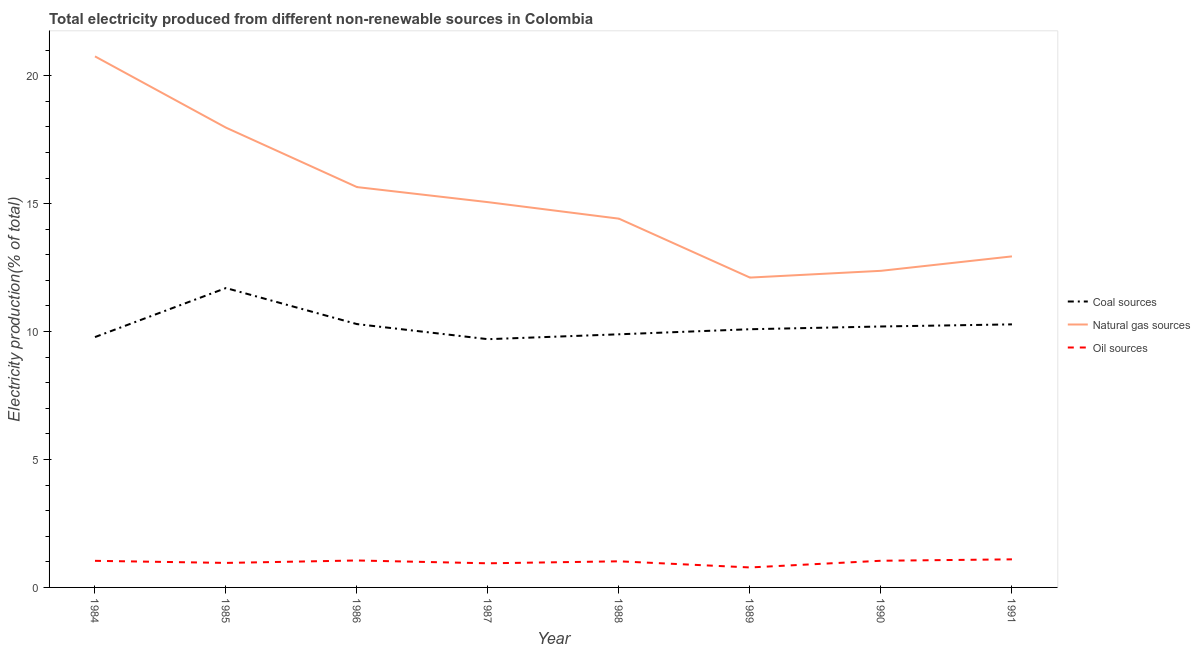Does the line corresponding to percentage of electricity produced by oil sources intersect with the line corresponding to percentage of electricity produced by natural gas?
Provide a succinct answer. No. Is the number of lines equal to the number of legend labels?
Ensure brevity in your answer.  Yes. What is the percentage of electricity produced by coal in 1988?
Your answer should be very brief. 9.89. Across all years, what is the maximum percentage of electricity produced by natural gas?
Your response must be concise. 20.76. Across all years, what is the minimum percentage of electricity produced by natural gas?
Your response must be concise. 12.11. What is the total percentage of electricity produced by oil sources in the graph?
Offer a very short reply. 7.94. What is the difference between the percentage of electricity produced by natural gas in 1988 and that in 1990?
Keep it short and to the point. 2.04. What is the difference between the percentage of electricity produced by oil sources in 1988 and the percentage of electricity produced by coal in 1991?
Your answer should be very brief. -9.26. What is the average percentage of electricity produced by natural gas per year?
Your answer should be compact. 15.16. In the year 1984, what is the difference between the percentage of electricity produced by coal and percentage of electricity produced by natural gas?
Offer a very short reply. -10.97. In how many years, is the percentage of electricity produced by oil sources greater than 18 %?
Ensure brevity in your answer.  0. What is the ratio of the percentage of electricity produced by natural gas in 1984 to that in 1986?
Your response must be concise. 1.33. What is the difference between the highest and the second highest percentage of electricity produced by coal?
Your response must be concise. 1.41. What is the difference between the highest and the lowest percentage of electricity produced by oil sources?
Offer a terse response. 0.32. In how many years, is the percentage of electricity produced by coal greater than the average percentage of electricity produced by coal taken over all years?
Ensure brevity in your answer.  3. Is the sum of the percentage of electricity produced by natural gas in 1984 and 1991 greater than the maximum percentage of electricity produced by oil sources across all years?
Offer a very short reply. Yes. Does the percentage of electricity produced by oil sources monotonically increase over the years?
Your response must be concise. No. Is the percentage of electricity produced by oil sources strictly less than the percentage of electricity produced by natural gas over the years?
Ensure brevity in your answer.  Yes. What is the difference between two consecutive major ticks on the Y-axis?
Ensure brevity in your answer.  5. Does the graph contain grids?
Your answer should be very brief. No. Where does the legend appear in the graph?
Ensure brevity in your answer.  Center right. How are the legend labels stacked?
Your response must be concise. Vertical. What is the title of the graph?
Ensure brevity in your answer.  Total electricity produced from different non-renewable sources in Colombia. What is the label or title of the Y-axis?
Make the answer very short. Electricity production(% of total). What is the Electricity production(% of total) in Coal sources in 1984?
Your answer should be compact. 9.78. What is the Electricity production(% of total) in Natural gas sources in 1984?
Ensure brevity in your answer.  20.76. What is the Electricity production(% of total) of Oil sources in 1984?
Your answer should be very brief. 1.04. What is the Electricity production(% of total) of Coal sources in 1985?
Keep it short and to the point. 11.7. What is the Electricity production(% of total) of Natural gas sources in 1985?
Keep it short and to the point. 17.97. What is the Electricity production(% of total) of Oil sources in 1985?
Provide a succinct answer. 0.96. What is the Electricity production(% of total) of Coal sources in 1986?
Your response must be concise. 10.29. What is the Electricity production(% of total) in Natural gas sources in 1986?
Offer a terse response. 15.65. What is the Electricity production(% of total) in Oil sources in 1986?
Offer a terse response. 1.05. What is the Electricity production(% of total) in Coal sources in 1987?
Ensure brevity in your answer.  9.7. What is the Electricity production(% of total) in Natural gas sources in 1987?
Ensure brevity in your answer.  15.06. What is the Electricity production(% of total) in Oil sources in 1987?
Keep it short and to the point. 0.94. What is the Electricity production(% of total) of Coal sources in 1988?
Your answer should be compact. 9.89. What is the Electricity production(% of total) of Natural gas sources in 1988?
Make the answer very short. 14.41. What is the Electricity production(% of total) in Oil sources in 1988?
Provide a succinct answer. 1.02. What is the Electricity production(% of total) of Coal sources in 1989?
Offer a very short reply. 10.09. What is the Electricity production(% of total) of Natural gas sources in 1989?
Offer a very short reply. 12.11. What is the Electricity production(% of total) of Oil sources in 1989?
Provide a succinct answer. 0.78. What is the Electricity production(% of total) of Coal sources in 1990?
Your answer should be very brief. 10.2. What is the Electricity production(% of total) in Natural gas sources in 1990?
Your answer should be compact. 12.37. What is the Electricity production(% of total) of Oil sources in 1990?
Offer a very short reply. 1.04. What is the Electricity production(% of total) of Coal sources in 1991?
Your answer should be compact. 10.28. What is the Electricity production(% of total) in Natural gas sources in 1991?
Make the answer very short. 12.94. What is the Electricity production(% of total) of Oil sources in 1991?
Provide a succinct answer. 1.1. Across all years, what is the maximum Electricity production(% of total) in Coal sources?
Provide a succinct answer. 11.7. Across all years, what is the maximum Electricity production(% of total) of Natural gas sources?
Provide a short and direct response. 20.76. Across all years, what is the maximum Electricity production(% of total) of Oil sources?
Make the answer very short. 1.1. Across all years, what is the minimum Electricity production(% of total) of Coal sources?
Ensure brevity in your answer.  9.7. Across all years, what is the minimum Electricity production(% of total) in Natural gas sources?
Offer a terse response. 12.11. Across all years, what is the minimum Electricity production(% of total) of Oil sources?
Your answer should be compact. 0.78. What is the total Electricity production(% of total) in Coal sources in the graph?
Provide a succinct answer. 81.95. What is the total Electricity production(% of total) of Natural gas sources in the graph?
Give a very brief answer. 121.27. What is the total Electricity production(% of total) in Oil sources in the graph?
Provide a succinct answer. 7.94. What is the difference between the Electricity production(% of total) in Coal sources in 1984 and that in 1985?
Your answer should be very brief. -1.92. What is the difference between the Electricity production(% of total) in Natural gas sources in 1984 and that in 1985?
Your response must be concise. 2.79. What is the difference between the Electricity production(% of total) of Oil sources in 1984 and that in 1985?
Keep it short and to the point. 0.08. What is the difference between the Electricity production(% of total) in Coal sources in 1984 and that in 1986?
Your answer should be very brief. -0.51. What is the difference between the Electricity production(% of total) in Natural gas sources in 1984 and that in 1986?
Give a very brief answer. 5.11. What is the difference between the Electricity production(% of total) in Oil sources in 1984 and that in 1986?
Make the answer very short. -0.01. What is the difference between the Electricity production(% of total) of Coal sources in 1984 and that in 1987?
Your answer should be very brief. 0.08. What is the difference between the Electricity production(% of total) in Natural gas sources in 1984 and that in 1987?
Offer a very short reply. 5.7. What is the difference between the Electricity production(% of total) in Oil sources in 1984 and that in 1987?
Keep it short and to the point. 0.1. What is the difference between the Electricity production(% of total) of Coal sources in 1984 and that in 1988?
Make the answer very short. -0.11. What is the difference between the Electricity production(% of total) in Natural gas sources in 1984 and that in 1988?
Offer a terse response. 6.34. What is the difference between the Electricity production(% of total) of Oil sources in 1984 and that in 1988?
Offer a very short reply. 0.02. What is the difference between the Electricity production(% of total) in Coal sources in 1984 and that in 1989?
Make the answer very short. -0.31. What is the difference between the Electricity production(% of total) of Natural gas sources in 1984 and that in 1989?
Provide a short and direct response. 8.65. What is the difference between the Electricity production(% of total) in Oil sources in 1984 and that in 1989?
Give a very brief answer. 0.26. What is the difference between the Electricity production(% of total) of Coal sources in 1984 and that in 1990?
Your answer should be very brief. -0.41. What is the difference between the Electricity production(% of total) of Natural gas sources in 1984 and that in 1990?
Give a very brief answer. 8.38. What is the difference between the Electricity production(% of total) in Oil sources in 1984 and that in 1990?
Ensure brevity in your answer.  -0. What is the difference between the Electricity production(% of total) in Coal sources in 1984 and that in 1991?
Offer a terse response. -0.5. What is the difference between the Electricity production(% of total) of Natural gas sources in 1984 and that in 1991?
Offer a very short reply. 7.82. What is the difference between the Electricity production(% of total) of Oil sources in 1984 and that in 1991?
Ensure brevity in your answer.  -0.06. What is the difference between the Electricity production(% of total) in Coal sources in 1985 and that in 1986?
Offer a very short reply. 1.41. What is the difference between the Electricity production(% of total) in Natural gas sources in 1985 and that in 1986?
Your response must be concise. 2.32. What is the difference between the Electricity production(% of total) of Oil sources in 1985 and that in 1986?
Your answer should be very brief. -0.1. What is the difference between the Electricity production(% of total) of Coal sources in 1985 and that in 1987?
Provide a succinct answer. 2. What is the difference between the Electricity production(% of total) of Natural gas sources in 1985 and that in 1987?
Keep it short and to the point. 2.91. What is the difference between the Electricity production(% of total) in Oil sources in 1985 and that in 1987?
Keep it short and to the point. 0.01. What is the difference between the Electricity production(% of total) in Coal sources in 1985 and that in 1988?
Ensure brevity in your answer.  1.81. What is the difference between the Electricity production(% of total) of Natural gas sources in 1985 and that in 1988?
Your response must be concise. 3.56. What is the difference between the Electricity production(% of total) in Oil sources in 1985 and that in 1988?
Provide a short and direct response. -0.06. What is the difference between the Electricity production(% of total) in Coal sources in 1985 and that in 1989?
Your response must be concise. 1.61. What is the difference between the Electricity production(% of total) in Natural gas sources in 1985 and that in 1989?
Your answer should be compact. 5.86. What is the difference between the Electricity production(% of total) in Oil sources in 1985 and that in 1989?
Your response must be concise. 0.18. What is the difference between the Electricity production(% of total) of Coal sources in 1985 and that in 1990?
Provide a succinct answer. 1.5. What is the difference between the Electricity production(% of total) in Natural gas sources in 1985 and that in 1990?
Offer a very short reply. 5.6. What is the difference between the Electricity production(% of total) in Oil sources in 1985 and that in 1990?
Offer a very short reply. -0.08. What is the difference between the Electricity production(% of total) of Coal sources in 1985 and that in 1991?
Provide a short and direct response. 1.42. What is the difference between the Electricity production(% of total) of Natural gas sources in 1985 and that in 1991?
Provide a short and direct response. 5.03. What is the difference between the Electricity production(% of total) of Oil sources in 1985 and that in 1991?
Your response must be concise. -0.14. What is the difference between the Electricity production(% of total) of Coal sources in 1986 and that in 1987?
Your answer should be very brief. 0.59. What is the difference between the Electricity production(% of total) in Natural gas sources in 1986 and that in 1987?
Your answer should be very brief. 0.59. What is the difference between the Electricity production(% of total) in Oil sources in 1986 and that in 1987?
Offer a terse response. 0.11. What is the difference between the Electricity production(% of total) of Coal sources in 1986 and that in 1988?
Give a very brief answer. 0.4. What is the difference between the Electricity production(% of total) in Natural gas sources in 1986 and that in 1988?
Give a very brief answer. 1.23. What is the difference between the Electricity production(% of total) of Oil sources in 1986 and that in 1988?
Make the answer very short. 0.03. What is the difference between the Electricity production(% of total) of Coal sources in 1986 and that in 1989?
Your answer should be very brief. 0.2. What is the difference between the Electricity production(% of total) in Natural gas sources in 1986 and that in 1989?
Keep it short and to the point. 3.54. What is the difference between the Electricity production(% of total) in Oil sources in 1986 and that in 1989?
Offer a terse response. 0.27. What is the difference between the Electricity production(% of total) of Coal sources in 1986 and that in 1990?
Your answer should be very brief. 0.09. What is the difference between the Electricity production(% of total) of Natural gas sources in 1986 and that in 1990?
Your response must be concise. 3.27. What is the difference between the Electricity production(% of total) of Oil sources in 1986 and that in 1990?
Your answer should be compact. 0.01. What is the difference between the Electricity production(% of total) of Coal sources in 1986 and that in 1991?
Ensure brevity in your answer.  0.01. What is the difference between the Electricity production(% of total) of Natural gas sources in 1986 and that in 1991?
Keep it short and to the point. 2.71. What is the difference between the Electricity production(% of total) of Oil sources in 1986 and that in 1991?
Make the answer very short. -0.04. What is the difference between the Electricity production(% of total) of Coal sources in 1987 and that in 1988?
Your answer should be very brief. -0.19. What is the difference between the Electricity production(% of total) in Natural gas sources in 1987 and that in 1988?
Your answer should be very brief. 0.65. What is the difference between the Electricity production(% of total) in Oil sources in 1987 and that in 1988?
Keep it short and to the point. -0.08. What is the difference between the Electricity production(% of total) in Coal sources in 1987 and that in 1989?
Offer a terse response. -0.39. What is the difference between the Electricity production(% of total) in Natural gas sources in 1987 and that in 1989?
Provide a succinct answer. 2.95. What is the difference between the Electricity production(% of total) in Oil sources in 1987 and that in 1989?
Offer a terse response. 0.16. What is the difference between the Electricity production(% of total) of Coal sources in 1987 and that in 1990?
Offer a terse response. -0.5. What is the difference between the Electricity production(% of total) in Natural gas sources in 1987 and that in 1990?
Give a very brief answer. 2.68. What is the difference between the Electricity production(% of total) of Oil sources in 1987 and that in 1990?
Provide a short and direct response. -0.1. What is the difference between the Electricity production(% of total) of Coal sources in 1987 and that in 1991?
Make the answer very short. -0.58. What is the difference between the Electricity production(% of total) of Natural gas sources in 1987 and that in 1991?
Keep it short and to the point. 2.12. What is the difference between the Electricity production(% of total) in Oil sources in 1987 and that in 1991?
Offer a very short reply. -0.15. What is the difference between the Electricity production(% of total) of Coal sources in 1988 and that in 1989?
Provide a succinct answer. -0.2. What is the difference between the Electricity production(% of total) of Natural gas sources in 1988 and that in 1989?
Provide a short and direct response. 2.3. What is the difference between the Electricity production(% of total) in Oil sources in 1988 and that in 1989?
Keep it short and to the point. 0.24. What is the difference between the Electricity production(% of total) in Coal sources in 1988 and that in 1990?
Your response must be concise. -0.31. What is the difference between the Electricity production(% of total) of Natural gas sources in 1988 and that in 1990?
Provide a succinct answer. 2.04. What is the difference between the Electricity production(% of total) of Oil sources in 1988 and that in 1990?
Your response must be concise. -0.02. What is the difference between the Electricity production(% of total) of Coal sources in 1988 and that in 1991?
Your response must be concise. -0.39. What is the difference between the Electricity production(% of total) in Natural gas sources in 1988 and that in 1991?
Your response must be concise. 1.47. What is the difference between the Electricity production(% of total) of Oil sources in 1988 and that in 1991?
Give a very brief answer. -0.08. What is the difference between the Electricity production(% of total) of Coal sources in 1989 and that in 1990?
Give a very brief answer. -0.11. What is the difference between the Electricity production(% of total) of Natural gas sources in 1989 and that in 1990?
Keep it short and to the point. -0.26. What is the difference between the Electricity production(% of total) in Oil sources in 1989 and that in 1990?
Offer a very short reply. -0.26. What is the difference between the Electricity production(% of total) of Coal sources in 1989 and that in 1991?
Ensure brevity in your answer.  -0.19. What is the difference between the Electricity production(% of total) in Natural gas sources in 1989 and that in 1991?
Your answer should be compact. -0.83. What is the difference between the Electricity production(% of total) in Oil sources in 1989 and that in 1991?
Your answer should be compact. -0.32. What is the difference between the Electricity production(% of total) of Coal sources in 1990 and that in 1991?
Offer a very short reply. -0.08. What is the difference between the Electricity production(% of total) of Natural gas sources in 1990 and that in 1991?
Ensure brevity in your answer.  -0.56. What is the difference between the Electricity production(% of total) of Oil sources in 1990 and that in 1991?
Provide a short and direct response. -0.06. What is the difference between the Electricity production(% of total) of Coal sources in 1984 and the Electricity production(% of total) of Natural gas sources in 1985?
Give a very brief answer. -8.19. What is the difference between the Electricity production(% of total) of Coal sources in 1984 and the Electricity production(% of total) of Oil sources in 1985?
Provide a short and direct response. 8.83. What is the difference between the Electricity production(% of total) in Natural gas sources in 1984 and the Electricity production(% of total) in Oil sources in 1985?
Keep it short and to the point. 19.8. What is the difference between the Electricity production(% of total) in Coal sources in 1984 and the Electricity production(% of total) in Natural gas sources in 1986?
Make the answer very short. -5.86. What is the difference between the Electricity production(% of total) of Coal sources in 1984 and the Electricity production(% of total) of Oil sources in 1986?
Your response must be concise. 8.73. What is the difference between the Electricity production(% of total) in Natural gas sources in 1984 and the Electricity production(% of total) in Oil sources in 1986?
Provide a succinct answer. 19.7. What is the difference between the Electricity production(% of total) of Coal sources in 1984 and the Electricity production(% of total) of Natural gas sources in 1987?
Make the answer very short. -5.27. What is the difference between the Electricity production(% of total) of Coal sources in 1984 and the Electricity production(% of total) of Oil sources in 1987?
Make the answer very short. 8.84. What is the difference between the Electricity production(% of total) in Natural gas sources in 1984 and the Electricity production(% of total) in Oil sources in 1987?
Offer a very short reply. 19.81. What is the difference between the Electricity production(% of total) in Coal sources in 1984 and the Electricity production(% of total) in Natural gas sources in 1988?
Offer a terse response. -4.63. What is the difference between the Electricity production(% of total) in Coal sources in 1984 and the Electricity production(% of total) in Oil sources in 1988?
Offer a very short reply. 8.76. What is the difference between the Electricity production(% of total) in Natural gas sources in 1984 and the Electricity production(% of total) in Oil sources in 1988?
Offer a terse response. 19.74. What is the difference between the Electricity production(% of total) of Coal sources in 1984 and the Electricity production(% of total) of Natural gas sources in 1989?
Your answer should be compact. -2.33. What is the difference between the Electricity production(% of total) in Coal sources in 1984 and the Electricity production(% of total) in Oil sources in 1989?
Provide a succinct answer. 9. What is the difference between the Electricity production(% of total) of Natural gas sources in 1984 and the Electricity production(% of total) of Oil sources in 1989?
Ensure brevity in your answer.  19.98. What is the difference between the Electricity production(% of total) in Coal sources in 1984 and the Electricity production(% of total) in Natural gas sources in 1990?
Offer a very short reply. -2.59. What is the difference between the Electricity production(% of total) in Coal sources in 1984 and the Electricity production(% of total) in Oil sources in 1990?
Ensure brevity in your answer.  8.74. What is the difference between the Electricity production(% of total) in Natural gas sources in 1984 and the Electricity production(% of total) in Oil sources in 1990?
Offer a terse response. 19.71. What is the difference between the Electricity production(% of total) of Coal sources in 1984 and the Electricity production(% of total) of Natural gas sources in 1991?
Ensure brevity in your answer.  -3.15. What is the difference between the Electricity production(% of total) in Coal sources in 1984 and the Electricity production(% of total) in Oil sources in 1991?
Provide a short and direct response. 8.69. What is the difference between the Electricity production(% of total) in Natural gas sources in 1984 and the Electricity production(% of total) in Oil sources in 1991?
Provide a succinct answer. 19.66. What is the difference between the Electricity production(% of total) in Coal sources in 1985 and the Electricity production(% of total) in Natural gas sources in 1986?
Ensure brevity in your answer.  -3.95. What is the difference between the Electricity production(% of total) of Coal sources in 1985 and the Electricity production(% of total) of Oil sources in 1986?
Offer a terse response. 10.65. What is the difference between the Electricity production(% of total) of Natural gas sources in 1985 and the Electricity production(% of total) of Oil sources in 1986?
Your answer should be very brief. 16.92. What is the difference between the Electricity production(% of total) in Coal sources in 1985 and the Electricity production(% of total) in Natural gas sources in 1987?
Make the answer very short. -3.36. What is the difference between the Electricity production(% of total) of Coal sources in 1985 and the Electricity production(% of total) of Oil sources in 1987?
Provide a succinct answer. 10.76. What is the difference between the Electricity production(% of total) of Natural gas sources in 1985 and the Electricity production(% of total) of Oil sources in 1987?
Your response must be concise. 17.03. What is the difference between the Electricity production(% of total) of Coal sources in 1985 and the Electricity production(% of total) of Natural gas sources in 1988?
Your response must be concise. -2.71. What is the difference between the Electricity production(% of total) of Coal sources in 1985 and the Electricity production(% of total) of Oil sources in 1988?
Your answer should be very brief. 10.68. What is the difference between the Electricity production(% of total) of Natural gas sources in 1985 and the Electricity production(% of total) of Oil sources in 1988?
Give a very brief answer. 16.95. What is the difference between the Electricity production(% of total) of Coal sources in 1985 and the Electricity production(% of total) of Natural gas sources in 1989?
Give a very brief answer. -0.41. What is the difference between the Electricity production(% of total) in Coal sources in 1985 and the Electricity production(% of total) in Oil sources in 1989?
Make the answer very short. 10.92. What is the difference between the Electricity production(% of total) in Natural gas sources in 1985 and the Electricity production(% of total) in Oil sources in 1989?
Make the answer very short. 17.19. What is the difference between the Electricity production(% of total) in Coal sources in 1985 and the Electricity production(% of total) in Natural gas sources in 1990?
Make the answer very short. -0.67. What is the difference between the Electricity production(% of total) in Coal sources in 1985 and the Electricity production(% of total) in Oil sources in 1990?
Offer a terse response. 10.66. What is the difference between the Electricity production(% of total) of Natural gas sources in 1985 and the Electricity production(% of total) of Oil sources in 1990?
Offer a terse response. 16.93. What is the difference between the Electricity production(% of total) of Coal sources in 1985 and the Electricity production(% of total) of Natural gas sources in 1991?
Your response must be concise. -1.24. What is the difference between the Electricity production(% of total) in Coal sources in 1985 and the Electricity production(% of total) in Oil sources in 1991?
Ensure brevity in your answer.  10.6. What is the difference between the Electricity production(% of total) in Natural gas sources in 1985 and the Electricity production(% of total) in Oil sources in 1991?
Make the answer very short. 16.87. What is the difference between the Electricity production(% of total) in Coal sources in 1986 and the Electricity production(% of total) in Natural gas sources in 1987?
Your answer should be very brief. -4.77. What is the difference between the Electricity production(% of total) in Coal sources in 1986 and the Electricity production(% of total) in Oil sources in 1987?
Your response must be concise. 9.35. What is the difference between the Electricity production(% of total) of Natural gas sources in 1986 and the Electricity production(% of total) of Oil sources in 1987?
Keep it short and to the point. 14.7. What is the difference between the Electricity production(% of total) in Coal sources in 1986 and the Electricity production(% of total) in Natural gas sources in 1988?
Your answer should be very brief. -4.12. What is the difference between the Electricity production(% of total) in Coal sources in 1986 and the Electricity production(% of total) in Oil sources in 1988?
Ensure brevity in your answer.  9.27. What is the difference between the Electricity production(% of total) in Natural gas sources in 1986 and the Electricity production(% of total) in Oil sources in 1988?
Give a very brief answer. 14.63. What is the difference between the Electricity production(% of total) in Coal sources in 1986 and the Electricity production(% of total) in Natural gas sources in 1989?
Make the answer very short. -1.82. What is the difference between the Electricity production(% of total) in Coal sources in 1986 and the Electricity production(% of total) in Oil sources in 1989?
Keep it short and to the point. 9.51. What is the difference between the Electricity production(% of total) of Natural gas sources in 1986 and the Electricity production(% of total) of Oil sources in 1989?
Your response must be concise. 14.87. What is the difference between the Electricity production(% of total) of Coal sources in 1986 and the Electricity production(% of total) of Natural gas sources in 1990?
Offer a terse response. -2.08. What is the difference between the Electricity production(% of total) in Coal sources in 1986 and the Electricity production(% of total) in Oil sources in 1990?
Ensure brevity in your answer.  9.25. What is the difference between the Electricity production(% of total) in Natural gas sources in 1986 and the Electricity production(% of total) in Oil sources in 1990?
Your response must be concise. 14.6. What is the difference between the Electricity production(% of total) in Coal sources in 1986 and the Electricity production(% of total) in Natural gas sources in 1991?
Provide a succinct answer. -2.65. What is the difference between the Electricity production(% of total) of Coal sources in 1986 and the Electricity production(% of total) of Oil sources in 1991?
Ensure brevity in your answer.  9.19. What is the difference between the Electricity production(% of total) in Natural gas sources in 1986 and the Electricity production(% of total) in Oil sources in 1991?
Provide a succinct answer. 14.55. What is the difference between the Electricity production(% of total) in Coal sources in 1987 and the Electricity production(% of total) in Natural gas sources in 1988?
Provide a succinct answer. -4.71. What is the difference between the Electricity production(% of total) of Coal sources in 1987 and the Electricity production(% of total) of Oil sources in 1988?
Make the answer very short. 8.68. What is the difference between the Electricity production(% of total) of Natural gas sources in 1987 and the Electricity production(% of total) of Oil sources in 1988?
Your answer should be compact. 14.04. What is the difference between the Electricity production(% of total) of Coal sources in 1987 and the Electricity production(% of total) of Natural gas sources in 1989?
Give a very brief answer. -2.41. What is the difference between the Electricity production(% of total) in Coal sources in 1987 and the Electricity production(% of total) in Oil sources in 1989?
Offer a terse response. 8.92. What is the difference between the Electricity production(% of total) of Natural gas sources in 1987 and the Electricity production(% of total) of Oil sources in 1989?
Your answer should be compact. 14.28. What is the difference between the Electricity production(% of total) of Coal sources in 1987 and the Electricity production(% of total) of Natural gas sources in 1990?
Offer a very short reply. -2.67. What is the difference between the Electricity production(% of total) of Coal sources in 1987 and the Electricity production(% of total) of Oil sources in 1990?
Provide a short and direct response. 8.66. What is the difference between the Electricity production(% of total) in Natural gas sources in 1987 and the Electricity production(% of total) in Oil sources in 1990?
Provide a short and direct response. 14.02. What is the difference between the Electricity production(% of total) of Coal sources in 1987 and the Electricity production(% of total) of Natural gas sources in 1991?
Offer a very short reply. -3.24. What is the difference between the Electricity production(% of total) in Coal sources in 1987 and the Electricity production(% of total) in Oil sources in 1991?
Offer a very short reply. 8.6. What is the difference between the Electricity production(% of total) in Natural gas sources in 1987 and the Electricity production(% of total) in Oil sources in 1991?
Give a very brief answer. 13.96. What is the difference between the Electricity production(% of total) in Coal sources in 1988 and the Electricity production(% of total) in Natural gas sources in 1989?
Offer a very short reply. -2.22. What is the difference between the Electricity production(% of total) in Coal sources in 1988 and the Electricity production(% of total) in Oil sources in 1989?
Provide a succinct answer. 9.11. What is the difference between the Electricity production(% of total) of Natural gas sources in 1988 and the Electricity production(% of total) of Oil sources in 1989?
Your response must be concise. 13.63. What is the difference between the Electricity production(% of total) of Coal sources in 1988 and the Electricity production(% of total) of Natural gas sources in 1990?
Provide a short and direct response. -2.48. What is the difference between the Electricity production(% of total) in Coal sources in 1988 and the Electricity production(% of total) in Oil sources in 1990?
Your answer should be very brief. 8.85. What is the difference between the Electricity production(% of total) of Natural gas sources in 1988 and the Electricity production(% of total) of Oil sources in 1990?
Your answer should be compact. 13.37. What is the difference between the Electricity production(% of total) in Coal sources in 1988 and the Electricity production(% of total) in Natural gas sources in 1991?
Ensure brevity in your answer.  -3.05. What is the difference between the Electricity production(% of total) of Coal sources in 1988 and the Electricity production(% of total) of Oil sources in 1991?
Make the answer very short. 8.8. What is the difference between the Electricity production(% of total) in Natural gas sources in 1988 and the Electricity production(% of total) in Oil sources in 1991?
Make the answer very short. 13.32. What is the difference between the Electricity production(% of total) of Coal sources in 1989 and the Electricity production(% of total) of Natural gas sources in 1990?
Make the answer very short. -2.28. What is the difference between the Electricity production(% of total) in Coal sources in 1989 and the Electricity production(% of total) in Oil sources in 1990?
Your answer should be compact. 9.05. What is the difference between the Electricity production(% of total) of Natural gas sources in 1989 and the Electricity production(% of total) of Oil sources in 1990?
Offer a very short reply. 11.07. What is the difference between the Electricity production(% of total) in Coal sources in 1989 and the Electricity production(% of total) in Natural gas sources in 1991?
Provide a short and direct response. -2.85. What is the difference between the Electricity production(% of total) in Coal sources in 1989 and the Electricity production(% of total) in Oil sources in 1991?
Make the answer very short. 8.99. What is the difference between the Electricity production(% of total) of Natural gas sources in 1989 and the Electricity production(% of total) of Oil sources in 1991?
Make the answer very short. 11.01. What is the difference between the Electricity production(% of total) of Coal sources in 1990 and the Electricity production(% of total) of Natural gas sources in 1991?
Keep it short and to the point. -2.74. What is the difference between the Electricity production(% of total) in Coal sources in 1990 and the Electricity production(% of total) in Oil sources in 1991?
Your answer should be compact. 9.1. What is the difference between the Electricity production(% of total) of Natural gas sources in 1990 and the Electricity production(% of total) of Oil sources in 1991?
Your answer should be compact. 11.28. What is the average Electricity production(% of total) in Coal sources per year?
Provide a short and direct response. 10.24. What is the average Electricity production(% of total) in Natural gas sources per year?
Ensure brevity in your answer.  15.16. What is the average Electricity production(% of total) in Oil sources per year?
Keep it short and to the point. 0.99. In the year 1984, what is the difference between the Electricity production(% of total) of Coal sources and Electricity production(% of total) of Natural gas sources?
Keep it short and to the point. -10.97. In the year 1984, what is the difference between the Electricity production(% of total) of Coal sources and Electricity production(% of total) of Oil sources?
Ensure brevity in your answer.  8.75. In the year 1984, what is the difference between the Electricity production(% of total) of Natural gas sources and Electricity production(% of total) of Oil sources?
Keep it short and to the point. 19.72. In the year 1985, what is the difference between the Electricity production(% of total) of Coal sources and Electricity production(% of total) of Natural gas sources?
Your answer should be compact. -6.27. In the year 1985, what is the difference between the Electricity production(% of total) of Coal sources and Electricity production(% of total) of Oil sources?
Ensure brevity in your answer.  10.74. In the year 1985, what is the difference between the Electricity production(% of total) in Natural gas sources and Electricity production(% of total) in Oil sources?
Your answer should be compact. 17.01. In the year 1986, what is the difference between the Electricity production(% of total) in Coal sources and Electricity production(% of total) in Natural gas sources?
Your response must be concise. -5.36. In the year 1986, what is the difference between the Electricity production(% of total) in Coal sources and Electricity production(% of total) in Oil sources?
Your answer should be compact. 9.24. In the year 1986, what is the difference between the Electricity production(% of total) in Natural gas sources and Electricity production(% of total) in Oil sources?
Provide a succinct answer. 14.59. In the year 1987, what is the difference between the Electricity production(% of total) of Coal sources and Electricity production(% of total) of Natural gas sources?
Give a very brief answer. -5.36. In the year 1987, what is the difference between the Electricity production(% of total) in Coal sources and Electricity production(% of total) in Oil sources?
Offer a very short reply. 8.76. In the year 1987, what is the difference between the Electricity production(% of total) of Natural gas sources and Electricity production(% of total) of Oil sources?
Your answer should be very brief. 14.12. In the year 1988, what is the difference between the Electricity production(% of total) of Coal sources and Electricity production(% of total) of Natural gas sources?
Offer a very short reply. -4.52. In the year 1988, what is the difference between the Electricity production(% of total) of Coal sources and Electricity production(% of total) of Oil sources?
Ensure brevity in your answer.  8.87. In the year 1988, what is the difference between the Electricity production(% of total) of Natural gas sources and Electricity production(% of total) of Oil sources?
Provide a short and direct response. 13.39. In the year 1989, what is the difference between the Electricity production(% of total) of Coal sources and Electricity production(% of total) of Natural gas sources?
Ensure brevity in your answer.  -2.02. In the year 1989, what is the difference between the Electricity production(% of total) in Coal sources and Electricity production(% of total) in Oil sources?
Keep it short and to the point. 9.31. In the year 1989, what is the difference between the Electricity production(% of total) in Natural gas sources and Electricity production(% of total) in Oil sources?
Make the answer very short. 11.33. In the year 1990, what is the difference between the Electricity production(% of total) in Coal sources and Electricity production(% of total) in Natural gas sources?
Keep it short and to the point. -2.18. In the year 1990, what is the difference between the Electricity production(% of total) of Coal sources and Electricity production(% of total) of Oil sources?
Your answer should be compact. 9.16. In the year 1990, what is the difference between the Electricity production(% of total) in Natural gas sources and Electricity production(% of total) in Oil sources?
Provide a short and direct response. 11.33. In the year 1991, what is the difference between the Electricity production(% of total) in Coal sources and Electricity production(% of total) in Natural gas sources?
Provide a short and direct response. -2.66. In the year 1991, what is the difference between the Electricity production(% of total) of Coal sources and Electricity production(% of total) of Oil sources?
Offer a terse response. 9.18. In the year 1991, what is the difference between the Electricity production(% of total) of Natural gas sources and Electricity production(% of total) of Oil sources?
Your answer should be very brief. 11.84. What is the ratio of the Electricity production(% of total) of Coal sources in 1984 to that in 1985?
Make the answer very short. 0.84. What is the ratio of the Electricity production(% of total) of Natural gas sources in 1984 to that in 1985?
Your answer should be very brief. 1.16. What is the ratio of the Electricity production(% of total) in Oil sources in 1984 to that in 1985?
Your response must be concise. 1.09. What is the ratio of the Electricity production(% of total) in Coal sources in 1984 to that in 1986?
Provide a succinct answer. 0.95. What is the ratio of the Electricity production(% of total) of Natural gas sources in 1984 to that in 1986?
Make the answer very short. 1.33. What is the ratio of the Electricity production(% of total) in Oil sources in 1984 to that in 1986?
Provide a succinct answer. 0.99. What is the ratio of the Electricity production(% of total) in Coal sources in 1984 to that in 1987?
Your answer should be compact. 1.01. What is the ratio of the Electricity production(% of total) in Natural gas sources in 1984 to that in 1987?
Provide a short and direct response. 1.38. What is the ratio of the Electricity production(% of total) in Oil sources in 1984 to that in 1987?
Give a very brief answer. 1.1. What is the ratio of the Electricity production(% of total) of Coal sources in 1984 to that in 1988?
Ensure brevity in your answer.  0.99. What is the ratio of the Electricity production(% of total) of Natural gas sources in 1984 to that in 1988?
Your response must be concise. 1.44. What is the ratio of the Electricity production(% of total) of Oil sources in 1984 to that in 1988?
Your response must be concise. 1.02. What is the ratio of the Electricity production(% of total) of Coal sources in 1984 to that in 1989?
Offer a terse response. 0.97. What is the ratio of the Electricity production(% of total) of Natural gas sources in 1984 to that in 1989?
Provide a succinct answer. 1.71. What is the ratio of the Electricity production(% of total) in Oil sources in 1984 to that in 1989?
Provide a short and direct response. 1.33. What is the ratio of the Electricity production(% of total) in Coal sources in 1984 to that in 1990?
Offer a terse response. 0.96. What is the ratio of the Electricity production(% of total) in Natural gas sources in 1984 to that in 1990?
Offer a very short reply. 1.68. What is the ratio of the Electricity production(% of total) of Oil sources in 1984 to that in 1990?
Offer a terse response. 1. What is the ratio of the Electricity production(% of total) in Coal sources in 1984 to that in 1991?
Keep it short and to the point. 0.95. What is the ratio of the Electricity production(% of total) in Natural gas sources in 1984 to that in 1991?
Offer a terse response. 1.6. What is the ratio of the Electricity production(% of total) of Oil sources in 1984 to that in 1991?
Your answer should be compact. 0.95. What is the ratio of the Electricity production(% of total) in Coal sources in 1985 to that in 1986?
Provide a succinct answer. 1.14. What is the ratio of the Electricity production(% of total) of Natural gas sources in 1985 to that in 1986?
Offer a terse response. 1.15. What is the ratio of the Electricity production(% of total) of Oil sources in 1985 to that in 1986?
Your answer should be compact. 0.91. What is the ratio of the Electricity production(% of total) in Coal sources in 1985 to that in 1987?
Your response must be concise. 1.21. What is the ratio of the Electricity production(% of total) of Natural gas sources in 1985 to that in 1987?
Offer a terse response. 1.19. What is the ratio of the Electricity production(% of total) of Oil sources in 1985 to that in 1987?
Your answer should be compact. 1.02. What is the ratio of the Electricity production(% of total) of Coal sources in 1985 to that in 1988?
Ensure brevity in your answer.  1.18. What is the ratio of the Electricity production(% of total) in Natural gas sources in 1985 to that in 1988?
Offer a very short reply. 1.25. What is the ratio of the Electricity production(% of total) in Oil sources in 1985 to that in 1988?
Your answer should be very brief. 0.94. What is the ratio of the Electricity production(% of total) of Coal sources in 1985 to that in 1989?
Your answer should be compact. 1.16. What is the ratio of the Electricity production(% of total) of Natural gas sources in 1985 to that in 1989?
Provide a short and direct response. 1.48. What is the ratio of the Electricity production(% of total) of Oil sources in 1985 to that in 1989?
Ensure brevity in your answer.  1.23. What is the ratio of the Electricity production(% of total) in Coal sources in 1985 to that in 1990?
Make the answer very short. 1.15. What is the ratio of the Electricity production(% of total) in Natural gas sources in 1985 to that in 1990?
Provide a succinct answer. 1.45. What is the ratio of the Electricity production(% of total) of Oil sources in 1985 to that in 1990?
Your answer should be very brief. 0.92. What is the ratio of the Electricity production(% of total) in Coal sources in 1985 to that in 1991?
Provide a short and direct response. 1.14. What is the ratio of the Electricity production(% of total) of Natural gas sources in 1985 to that in 1991?
Keep it short and to the point. 1.39. What is the ratio of the Electricity production(% of total) of Oil sources in 1985 to that in 1991?
Keep it short and to the point. 0.87. What is the ratio of the Electricity production(% of total) in Coal sources in 1986 to that in 1987?
Provide a short and direct response. 1.06. What is the ratio of the Electricity production(% of total) of Natural gas sources in 1986 to that in 1987?
Ensure brevity in your answer.  1.04. What is the ratio of the Electricity production(% of total) of Oil sources in 1986 to that in 1987?
Your answer should be compact. 1.12. What is the ratio of the Electricity production(% of total) of Coal sources in 1986 to that in 1988?
Your response must be concise. 1.04. What is the ratio of the Electricity production(% of total) in Natural gas sources in 1986 to that in 1988?
Provide a short and direct response. 1.09. What is the ratio of the Electricity production(% of total) of Oil sources in 1986 to that in 1988?
Provide a succinct answer. 1.03. What is the ratio of the Electricity production(% of total) in Coal sources in 1986 to that in 1989?
Your answer should be very brief. 1.02. What is the ratio of the Electricity production(% of total) of Natural gas sources in 1986 to that in 1989?
Your response must be concise. 1.29. What is the ratio of the Electricity production(% of total) in Oil sources in 1986 to that in 1989?
Offer a very short reply. 1.35. What is the ratio of the Electricity production(% of total) of Coal sources in 1986 to that in 1990?
Offer a very short reply. 1.01. What is the ratio of the Electricity production(% of total) in Natural gas sources in 1986 to that in 1990?
Your answer should be compact. 1.26. What is the ratio of the Electricity production(% of total) in Oil sources in 1986 to that in 1990?
Offer a terse response. 1.01. What is the ratio of the Electricity production(% of total) in Coal sources in 1986 to that in 1991?
Provide a succinct answer. 1. What is the ratio of the Electricity production(% of total) in Natural gas sources in 1986 to that in 1991?
Your response must be concise. 1.21. What is the ratio of the Electricity production(% of total) of Oil sources in 1986 to that in 1991?
Provide a succinct answer. 0.96. What is the ratio of the Electricity production(% of total) in Coal sources in 1987 to that in 1988?
Make the answer very short. 0.98. What is the ratio of the Electricity production(% of total) of Natural gas sources in 1987 to that in 1988?
Keep it short and to the point. 1.04. What is the ratio of the Electricity production(% of total) in Oil sources in 1987 to that in 1988?
Offer a very short reply. 0.92. What is the ratio of the Electricity production(% of total) of Coal sources in 1987 to that in 1989?
Make the answer very short. 0.96. What is the ratio of the Electricity production(% of total) of Natural gas sources in 1987 to that in 1989?
Make the answer very short. 1.24. What is the ratio of the Electricity production(% of total) in Oil sources in 1987 to that in 1989?
Give a very brief answer. 1.21. What is the ratio of the Electricity production(% of total) of Coal sources in 1987 to that in 1990?
Offer a terse response. 0.95. What is the ratio of the Electricity production(% of total) in Natural gas sources in 1987 to that in 1990?
Make the answer very short. 1.22. What is the ratio of the Electricity production(% of total) in Oil sources in 1987 to that in 1990?
Provide a short and direct response. 0.9. What is the ratio of the Electricity production(% of total) of Coal sources in 1987 to that in 1991?
Ensure brevity in your answer.  0.94. What is the ratio of the Electricity production(% of total) of Natural gas sources in 1987 to that in 1991?
Your response must be concise. 1.16. What is the ratio of the Electricity production(% of total) of Oil sources in 1987 to that in 1991?
Make the answer very short. 0.86. What is the ratio of the Electricity production(% of total) of Coal sources in 1988 to that in 1989?
Make the answer very short. 0.98. What is the ratio of the Electricity production(% of total) in Natural gas sources in 1988 to that in 1989?
Provide a short and direct response. 1.19. What is the ratio of the Electricity production(% of total) in Oil sources in 1988 to that in 1989?
Your response must be concise. 1.31. What is the ratio of the Electricity production(% of total) of Coal sources in 1988 to that in 1990?
Your response must be concise. 0.97. What is the ratio of the Electricity production(% of total) of Natural gas sources in 1988 to that in 1990?
Make the answer very short. 1.16. What is the ratio of the Electricity production(% of total) in Oil sources in 1988 to that in 1990?
Make the answer very short. 0.98. What is the ratio of the Electricity production(% of total) of Coal sources in 1988 to that in 1991?
Keep it short and to the point. 0.96. What is the ratio of the Electricity production(% of total) in Natural gas sources in 1988 to that in 1991?
Offer a terse response. 1.11. What is the ratio of the Electricity production(% of total) in Oil sources in 1988 to that in 1991?
Keep it short and to the point. 0.93. What is the ratio of the Electricity production(% of total) of Coal sources in 1989 to that in 1990?
Keep it short and to the point. 0.99. What is the ratio of the Electricity production(% of total) in Natural gas sources in 1989 to that in 1990?
Ensure brevity in your answer.  0.98. What is the ratio of the Electricity production(% of total) in Oil sources in 1989 to that in 1990?
Keep it short and to the point. 0.75. What is the ratio of the Electricity production(% of total) of Coal sources in 1989 to that in 1991?
Provide a short and direct response. 0.98. What is the ratio of the Electricity production(% of total) in Natural gas sources in 1989 to that in 1991?
Your answer should be compact. 0.94. What is the ratio of the Electricity production(% of total) in Oil sources in 1989 to that in 1991?
Make the answer very short. 0.71. What is the ratio of the Electricity production(% of total) of Natural gas sources in 1990 to that in 1991?
Offer a terse response. 0.96. What is the ratio of the Electricity production(% of total) of Oil sources in 1990 to that in 1991?
Provide a succinct answer. 0.95. What is the difference between the highest and the second highest Electricity production(% of total) of Coal sources?
Your answer should be very brief. 1.41. What is the difference between the highest and the second highest Electricity production(% of total) in Natural gas sources?
Provide a succinct answer. 2.79. What is the difference between the highest and the second highest Electricity production(% of total) in Oil sources?
Your response must be concise. 0.04. What is the difference between the highest and the lowest Electricity production(% of total) of Coal sources?
Your response must be concise. 2. What is the difference between the highest and the lowest Electricity production(% of total) of Natural gas sources?
Your answer should be very brief. 8.65. What is the difference between the highest and the lowest Electricity production(% of total) of Oil sources?
Keep it short and to the point. 0.32. 